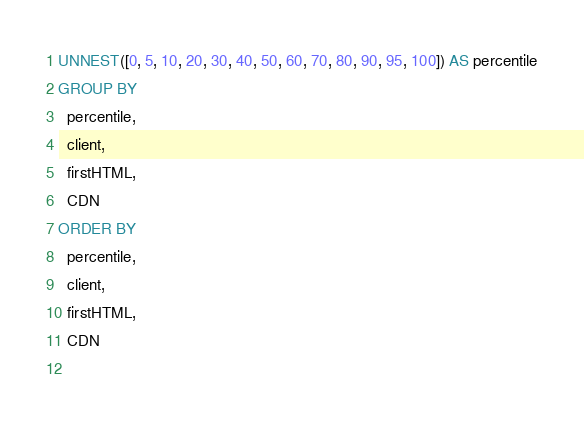<code> <loc_0><loc_0><loc_500><loc_500><_SQL_>UNNEST([0, 5, 10, 20, 30, 40, 50, 60, 70, 80, 90, 95, 100]) AS percentile
GROUP BY
  percentile,
  client,
  firstHTML,
  CDN
ORDER BY
  percentile,
  client,
  firstHTML,
  CDN
  </code> 